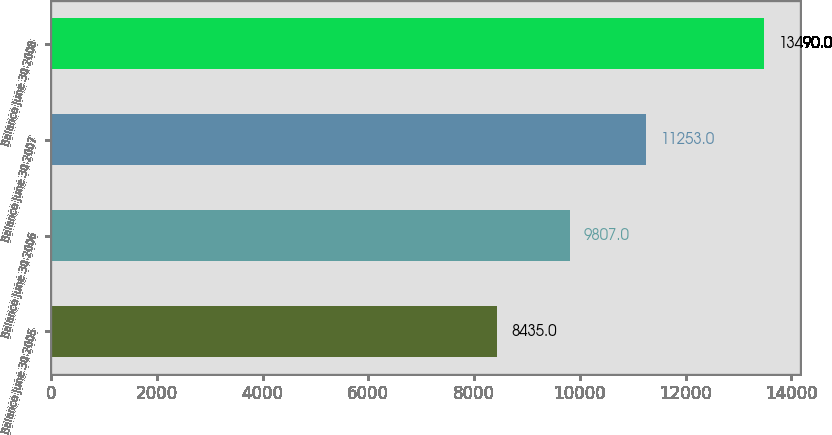Convert chart to OTSL. <chart><loc_0><loc_0><loc_500><loc_500><bar_chart><fcel>Balance June 30 2005<fcel>Balance June 30 2006<fcel>Balance June 30 2007<fcel>Balance June 30 2008<nl><fcel>8435<fcel>9807<fcel>11253<fcel>13490<nl></chart> 